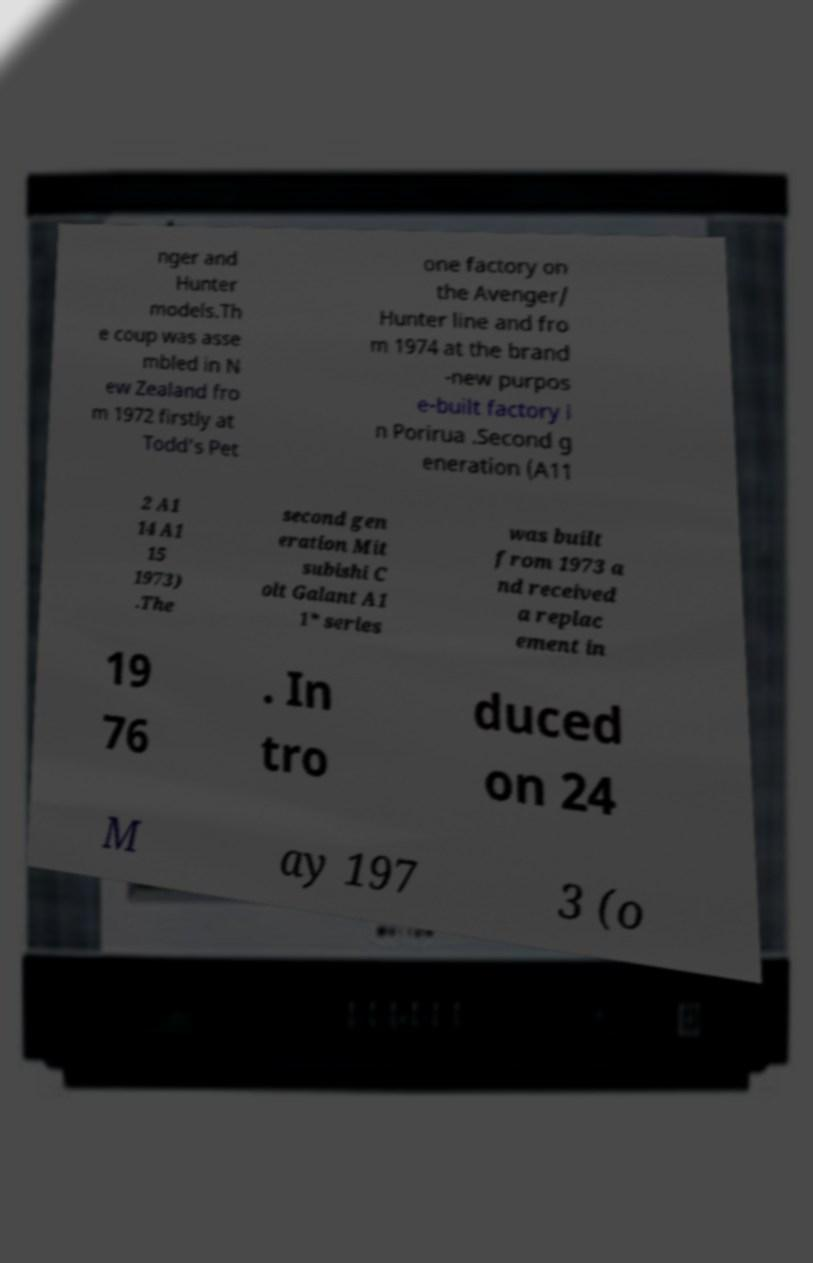Can you read and provide the text displayed in the image?This photo seems to have some interesting text. Can you extract and type it out for me? nger and Hunter models.Th e coup was asse mbled in N ew Zealand fro m 1972 firstly at Todd's Pet one factory on the Avenger/ Hunter line and fro m 1974 at the brand -new purpos e-built factory i n Porirua .Second g eneration (A11 2 A1 14 A1 15 1973) .The second gen eration Mit subishi C olt Galant A1 1* series was built from 1973 a nd received a replac ement in 19 76 . In tro duced on 24 M ay 197 3 (o 